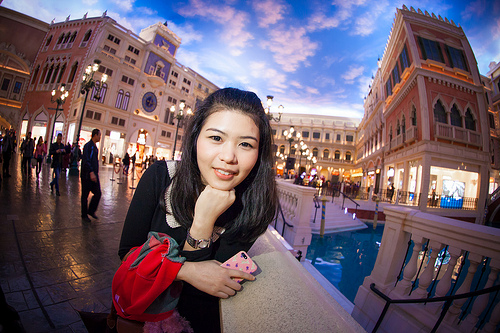<image>
Is there a water behind the building? Yes. From this viewpoint, the water is positioned behind the building, with the building partially or fully occluding the water. Where is the women in relation to the building? Is it behind the building? No. The women is not behind the building. From this viewpoint, the women appears to be positioned elsewhere in the scene. 